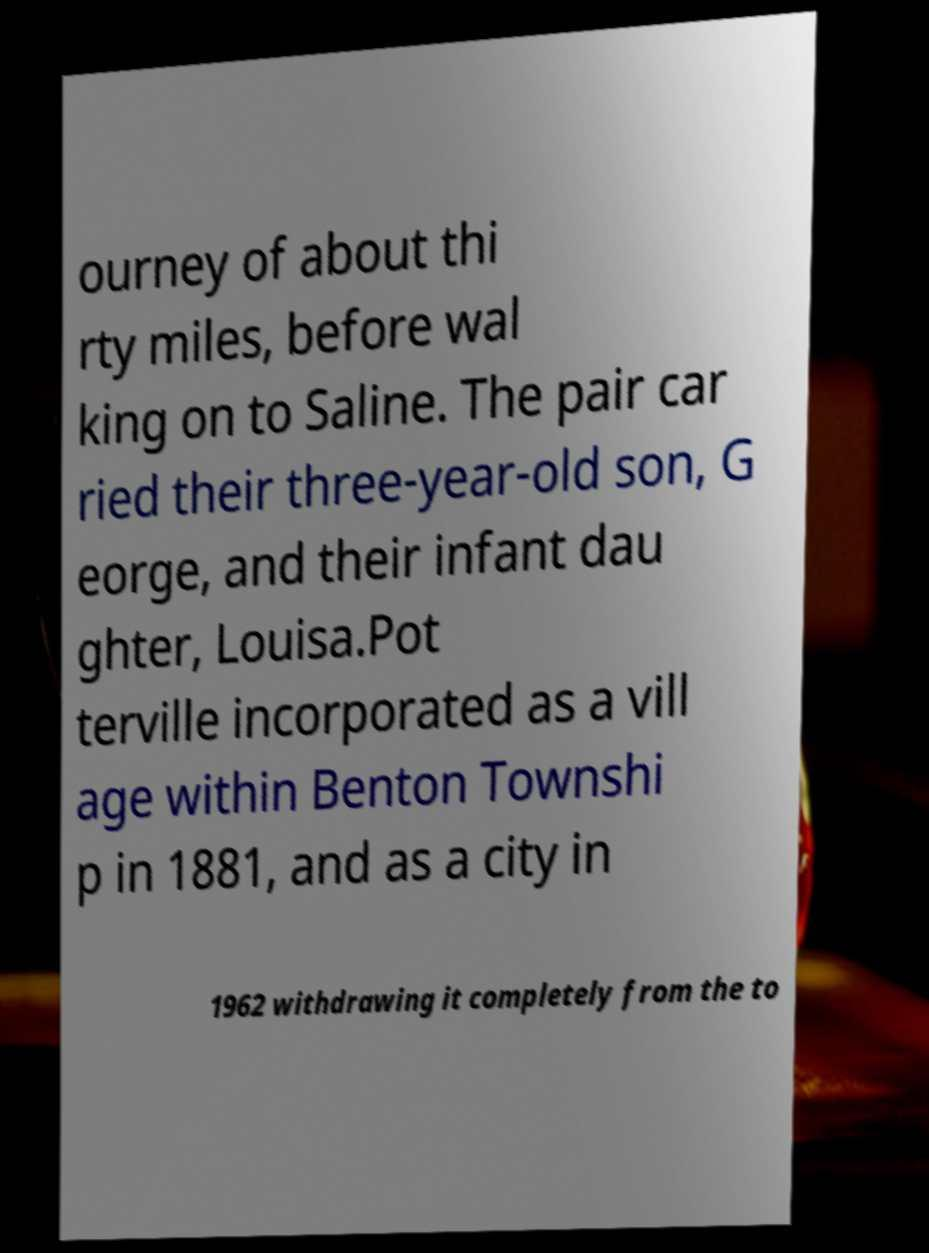Could you extract and type out the text from this image? ourney of about thi rty miles, before wal king on to Saline. The pair car ried their three-year-old son, G eorge, and their infant dau ghter, Louisa.Pot terville incorporated as a vill age within Benton Townshi p in 1881, and as a city in 1962 withdrawing it completely from the to 